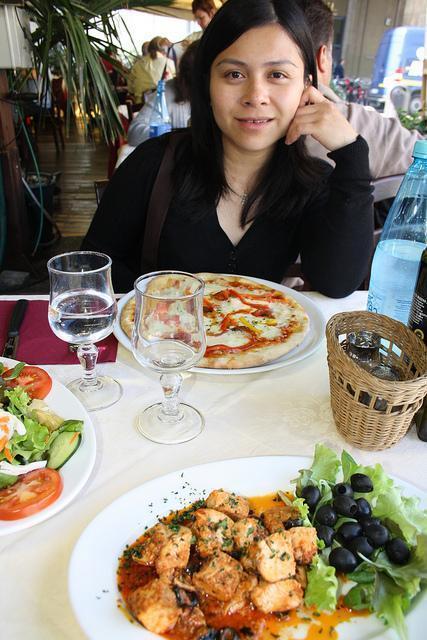What is the woman in black about to eat?
Indicate the correct response by choosing from the four available options to answer the question.
Options: Hamburger, pizza, egg, hot dog. Pizza. 